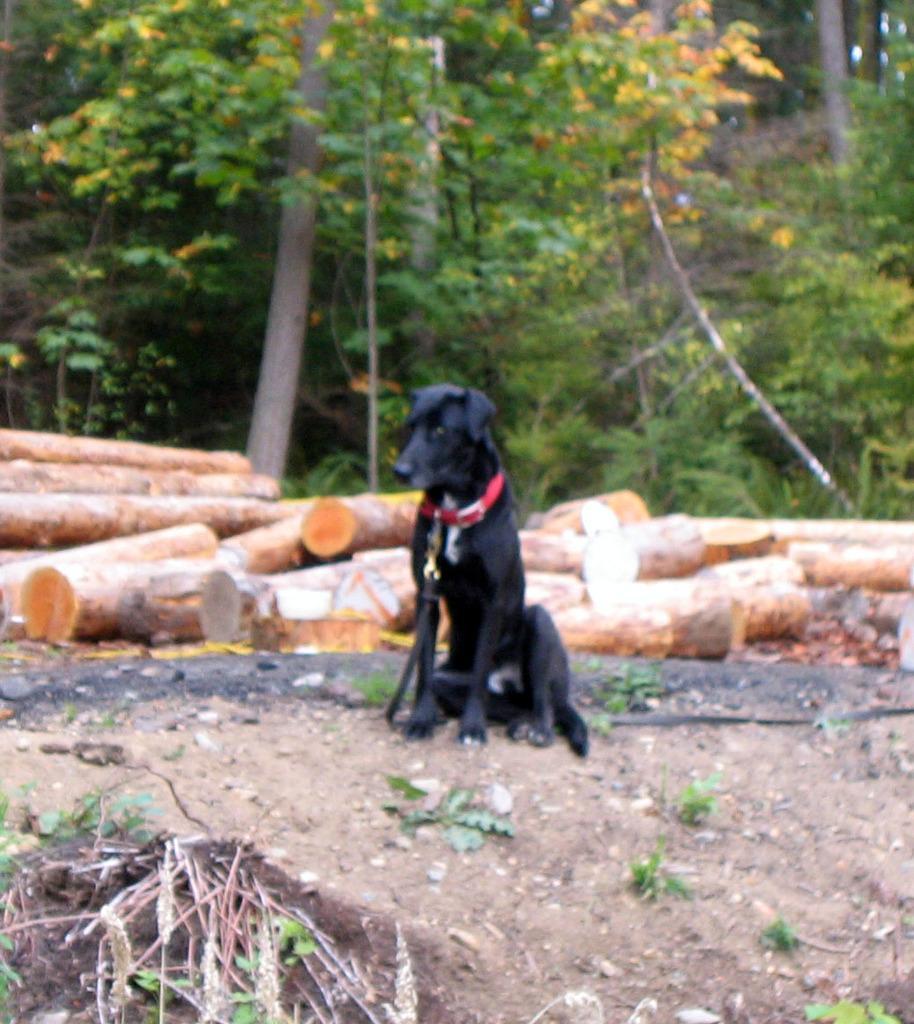Please provide a concise description of this image. This picture is clicked outside. In the center there is a black color dog sitting on the ground and we can see the trunks of the trees are placed on the ground. In the background we can see the trees and plants. 